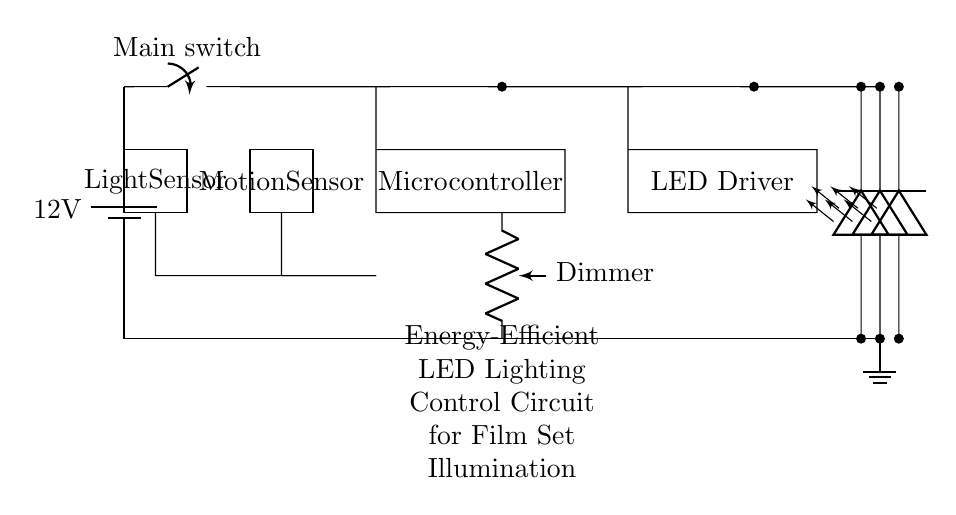What is the voltage used in the circuit? The circuit uses a 12V battery as indicated by the label near the battery symbol.
Answer: 12 volts What component controls the LED brightness? The dimmer component connected to the LED driver regulates the intensity of the LEDs by controlling the current flow.
Answer: Dimmer How many LED arrays are present in the circuit? There are three LED arrays depicted as three separate LED symbols in parallel connection shown on the right side of the diagram.
Answer: Three What type of sensors are included in this circuit? The circuit includes a motion sensor and a light sensor, indicated by their labels and rectangular shapes, which help control the lighting based on environmental conditions.
Answer: Motion sensor and light sensor How does the circuit respond to brightness levels? The light sensor detects ambient light levels, and it sends this information to the microcontroller, which then adjusts the LED lighting accordingly to maintain energy efficiency.
Answer: It responds to adjust LED brightness 